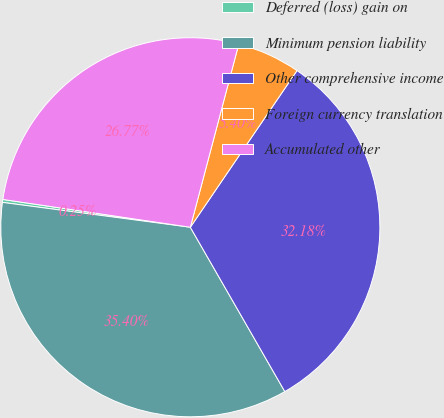Convert chart to OTSL. <chart><loc_0><loc_0><loc_500><loc_500><pie_chart><fcel>Deferred (loss) gain on<fcel>Minimum pension liability<fcel>Other comprehensive income<fcel>Foreign currency translation<fcel>Accumulated other<nl><fcel>0.25%<fcel>35.4%<fcel>32.18%<fcel>5.4%<fcel>26.77%<nl></chart> 